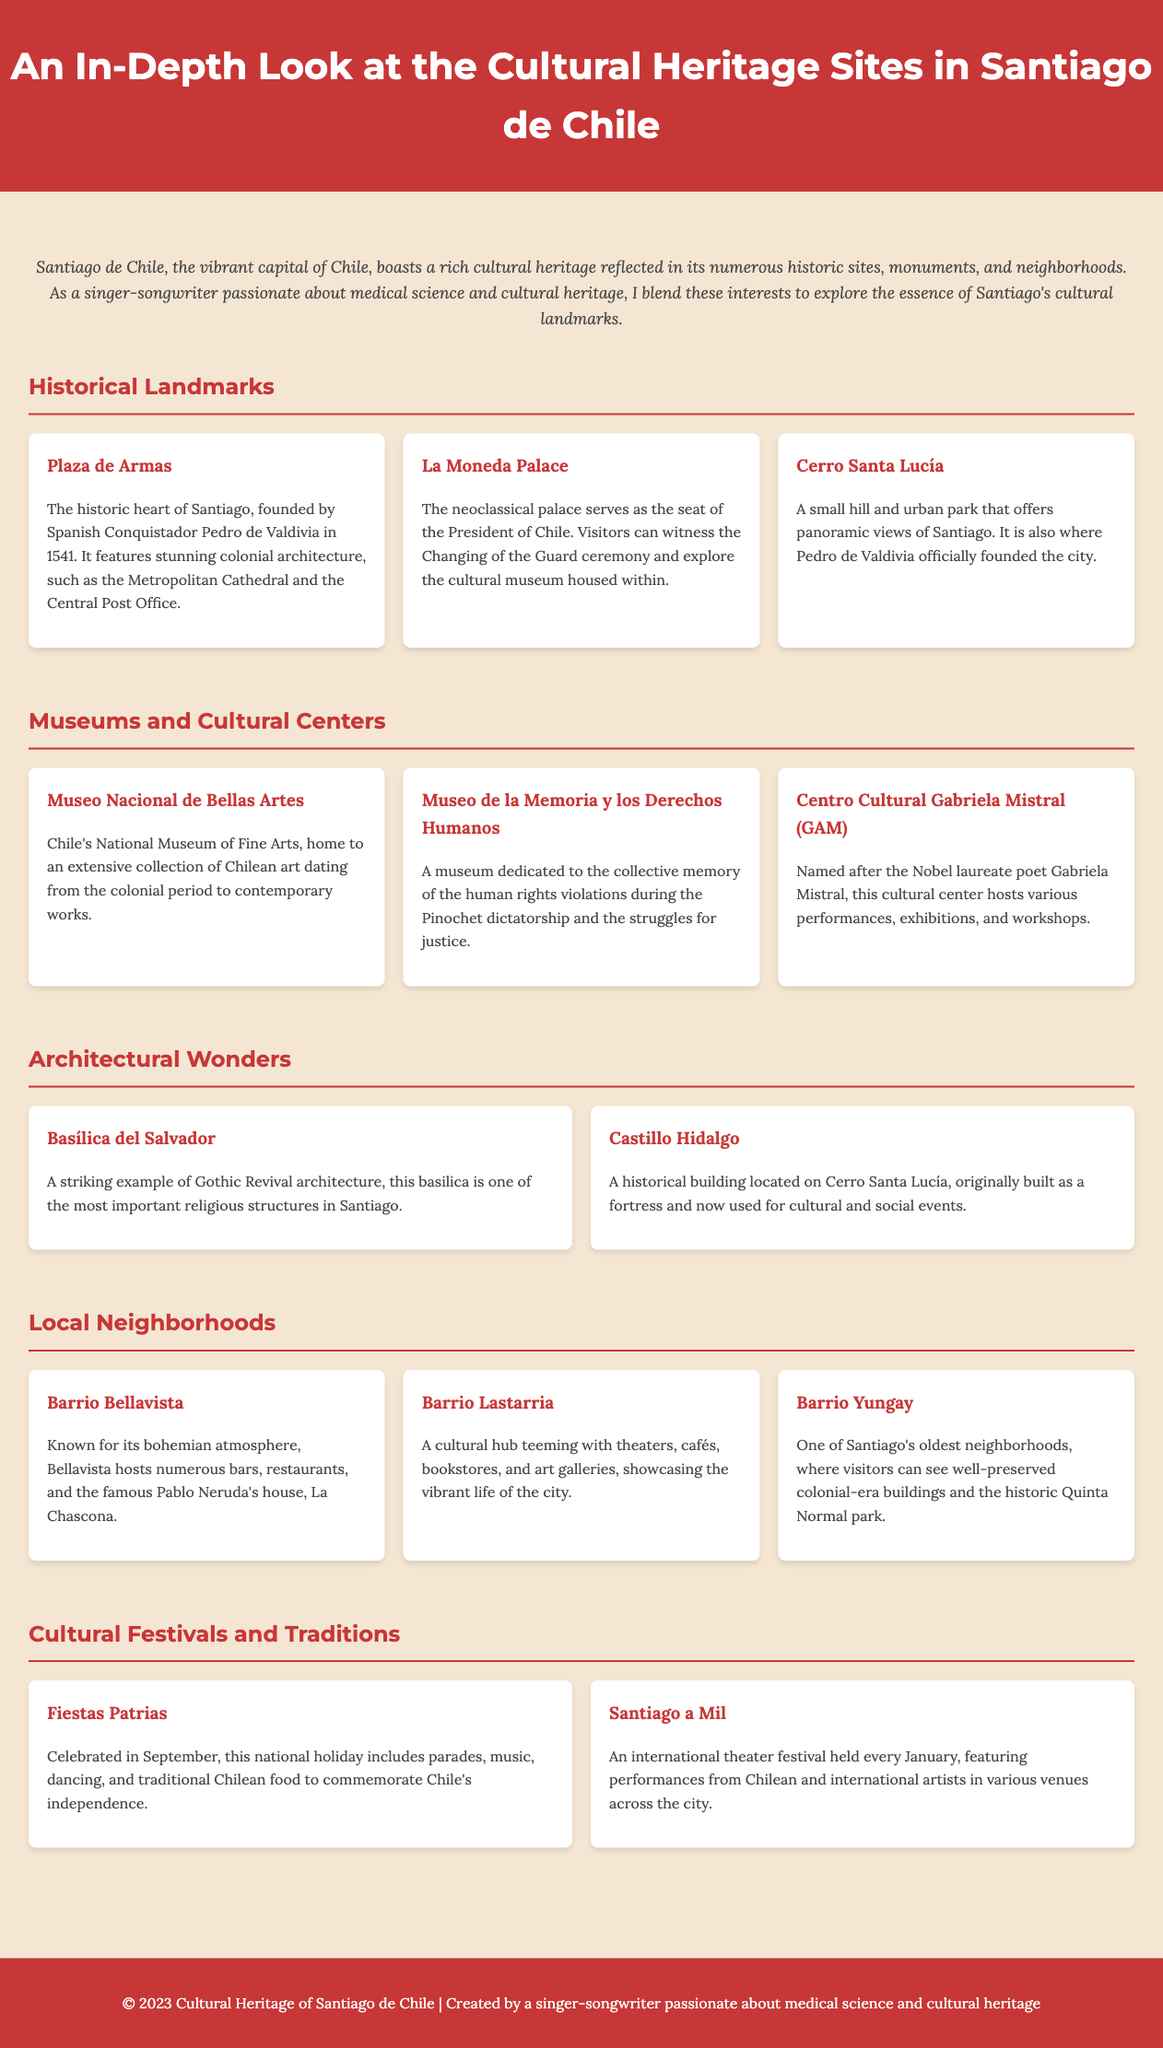What historical landmark in Santiago was founded in 1541? The document states that Plaza de Armas was founded by Spanish Conquistador Pedro de Valdivia in 1541.
Answer: Plaza de Armas What is the name of the cultural center named after a Nobel laureate poet? The Centro Cultural Gabriela Mistral (GAM) is named after Nobel laureate poet Gabriela Mistral, as mentioned in the document.
Answer: Centro Cultural Gabriela Mistral (GAM) Which neighborhood is known for its bohemian atmosphere? The document mentions that Barrio Bellavista is known for its bohemian atmosphere with bars and restaurants.
Answer: Barrio Bellavista What event is celebrated in September to commemorate Chile's independence? According to the document, Fiestas Patrias is celebrated in September for Chile's independence.
Answer: Fiestas Patrias How many museums are mentioned in the infographic? The document lists three museums under the Museums and Cultural Centers section.
Answer: Three What architectural style is the Basílica del Salvador? The document specifies that the Basílica del Salvador is an example of Gothic Revival architecture.
Answer: Gothic Revival What is one activity you can witness at La Moneda Palace? The Changing of the Guard ceremony is an activity mentioned that visitors can witness at La Moneda Palace.
Answer: Changing of the Guard ceremony Which festival is an international theater festival held every January? Santiago a Mil is described as an international theater festival held every January in the document.
Answer: Santiago a Mil What type of buildings can be seen in Barrio Yungay? The document notes that Barrio Yungay features well-preserved colonial-era buildings.
Answer: Colonial-era buildings 